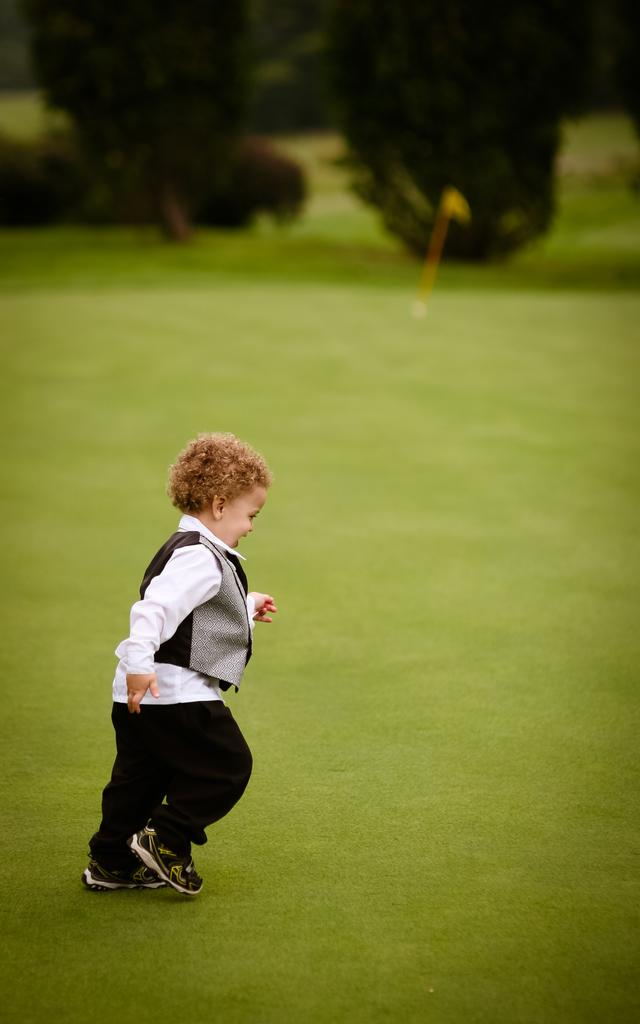What is the main subject of the image? The main subject of the image is a kid. What is the kid wearing? The kid is wearing a white and black dress. What is the kid doing in the image? The kid is running. What type of terrain is visible in the image? There is green grass on the ground in the image. What can be seen in the background of the image? There are trees in the background of the image. What type of loaf is the kid holding in the image? There is no loaf present in the image; the kid is running and wearing a white and black dress. 